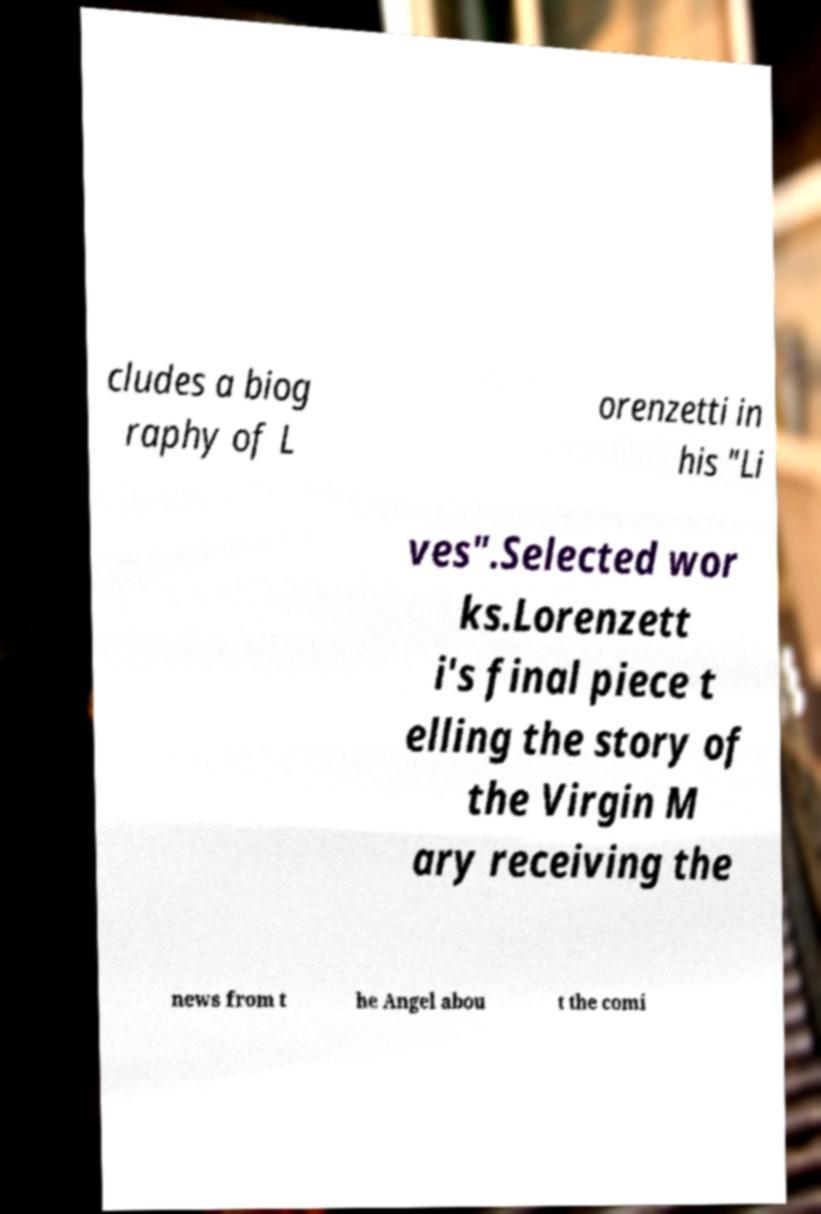What messages or text are displayed in this image? I need them in a readable, typed format. cludes a biog raphy of L orenzetti in his "Li ves".Selected wor ks.Lorenzett i's final piece t elling the story of the Virgin M ary receiving the news from t he Angel abou t the comi 